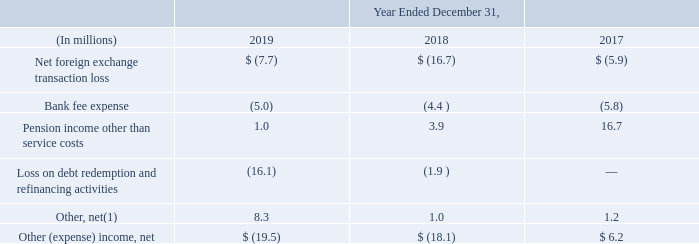Note 23 Other (Expense) Income, net
The following table provides details of other (expense) income, net:
(1) Cryovac Brasil Ltda., a Sealed Air subsidiary, received a final decision from the Brazilian court regarding a claim in which Sealed Air contended that certain indirect taxes paid were calculated on an incorrect amount. As a result, for the year ended December 31, 2019, we recorded income of $4.8 million to Other, net for a claim of overpaid taxes related to 2015 through 2018.
What was the final decision from the Brazilian court received by Cryovac Brasil Ltda., a Sealed Air subsidiary and the consequence? That certain indirect taxes paid were calculated on an incorrect amount. as a result, for the year ended december 31, 2019, we recorded income of $4.8 million to other, net for a claim of overpaid taxes related to 2015 through 2018. What does the table represent? Details of other (expense) income, net. What is the Other expense, net for 2019?
Answer scale should be: million. 19.5. Excluding the net for a claim of overpaid taxes related to 2015 through 2018 for 2019, what is the Other, net for 2019?
Answer scale should be: million. 8.3-4.8
Answer: 3.5. What is the average annual Other expense, net for the 3 years?
Answer scale should be: million. (19.5+18.1-6.2)/3
Answer: 10.47. What is the Net foreign exchange transaction loss expressed as a percentage of othe expense, net for 2019?
Answer scale should be: percent. 7.7/19.5
Answer: 39.49. 